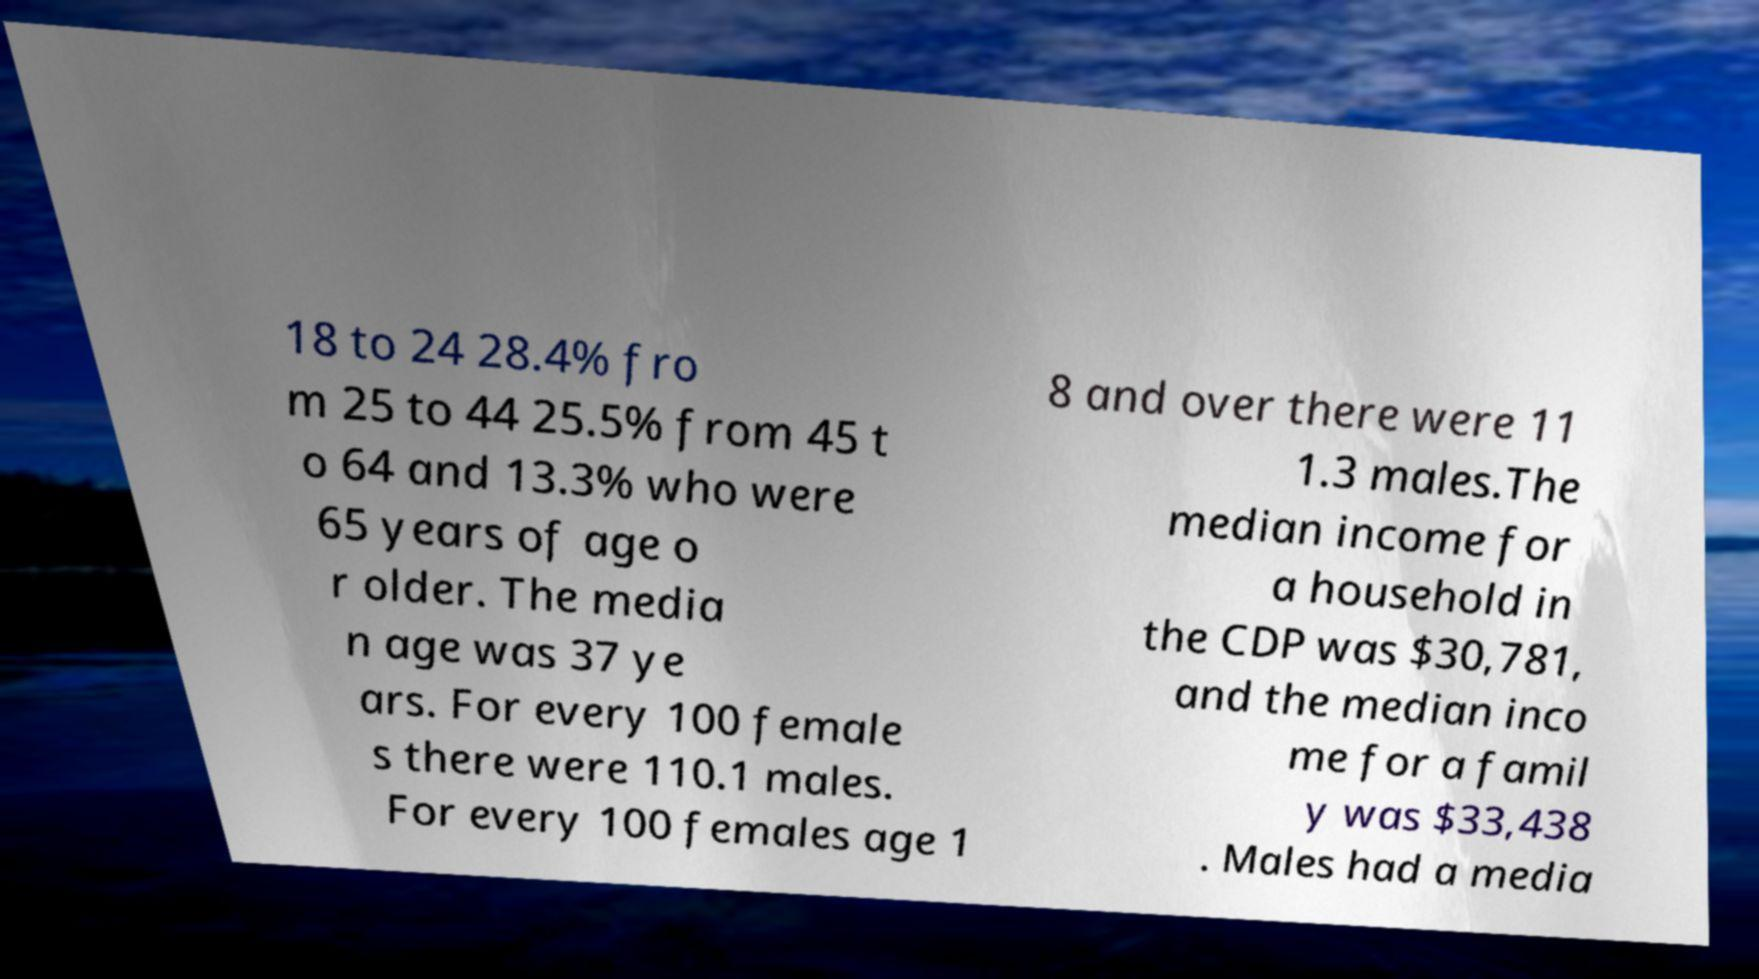Could you extract and type out the text from this image? 18 to 24 28.4% fro m 25 to 44 25.5% from 45 t o 64 and 13.3% who were 65 years of age o r older. The media n age was 37 ye ars. For every 100 female s there were 110.1 males. For every 100 females age 1 8 and over there were 11 1.3 males.The median income for a household in the CDP was $30,781, and the median inco me for a famil y was $33,438 . Males had a media 